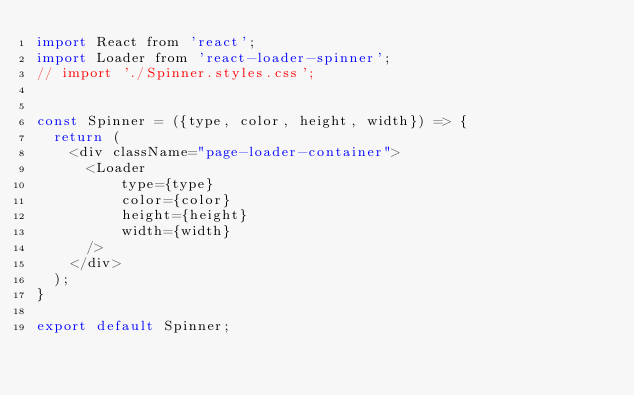Convert code to text. <code><loc_0><loc_0><loc_500><loc_500><_JavaScript_>import React from 'react';
import Loader from 'react-loader-spinner';
// import './Spinner.styles.css';


const Spinner = ({type, color, height, width}) => {
  return ( 
    <div className="page-loader-container">
      <Loader
          type={type}
          color={color}
          height={height}
          width={width}
      />
    </div>
  );
}
 
export default Spinner;</code> 